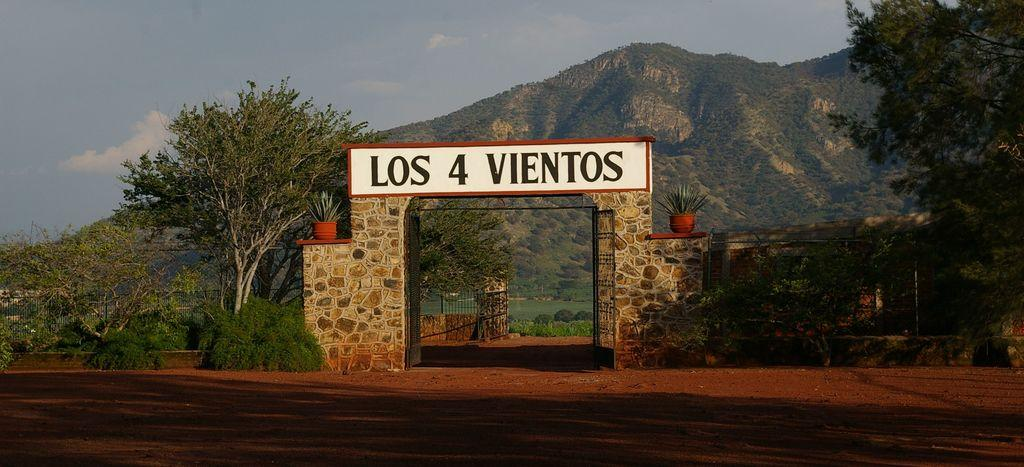What is located in the foreground of the image? There is an entrance gate in the foreground of the image. What is written on the board near the gate? The board near the gate has the text "LOS 4 VIENTOS" written on it. What type of vegetation can be seen in the image? There are plants and trees in the image. What type of structure is visible in the image? There is a wall in the image. What natural feature can be seen in the background of the image? There are mountains in the image. What is attached to the wall in the image? There is a railing in the image. What is visible in the sky in the image? The sky is visible in the image, and there are clouds in the sky. How many apples are hanging from the trees in the image? There is no mention of apples in the image, so it is impossible to determine how many apples are hanging from the trees. 